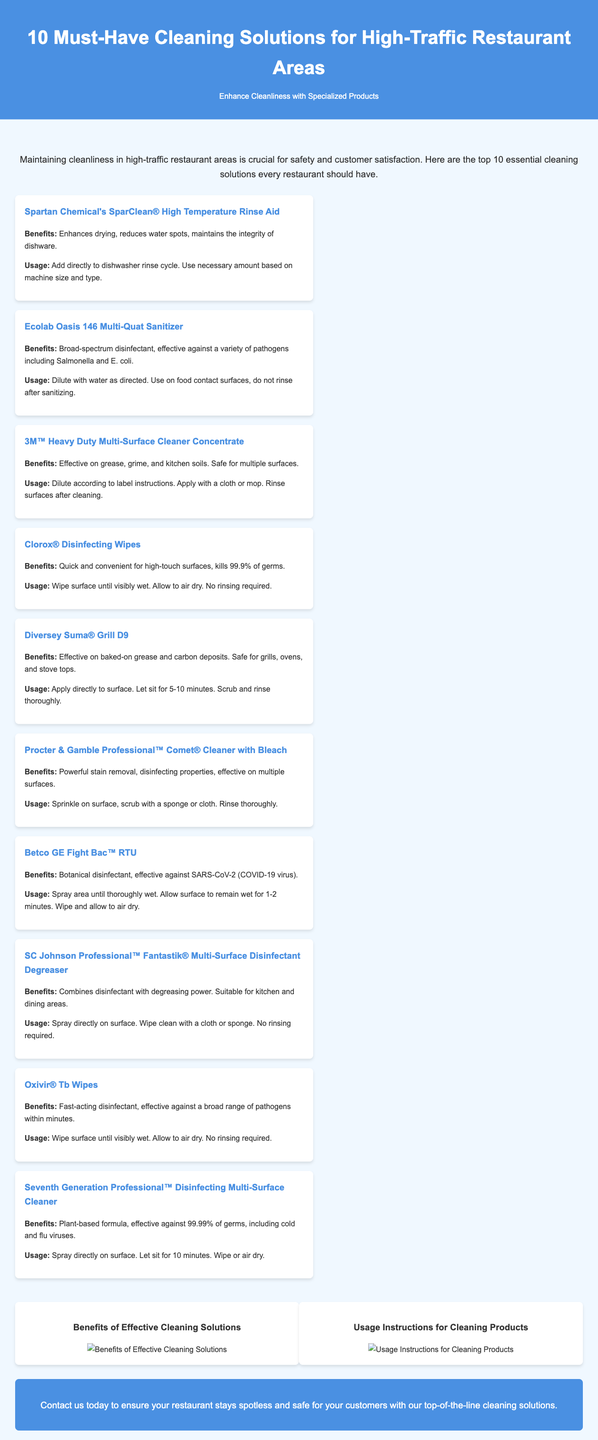What is the title of the document? The title is presented prominently at the top of the document, indicating the main topic.
Answer: 10 Must-Have Cleaning Solutions for High-Traffic Restaurant Areas How many cleaning solutions are listed? The introduction states that there are ten essential cleaning solutions mentioned in the document.
Answer: 10 What is a benefit of Spartan Chemical's SparClean® High Temperature Rinse Aid? Each product section discusses its benefits, and SparClean is noted for enhancing drying.
Answer: Enhances drying What type of disinfectant is Betco GE Fight Bac™ RTU? The document specifies that it is a botanical disinfectant, and this information is included in Betco's description.
Answer: Botanical What surfaces can the 3M™ Heavy Duty Multi-Surface Cleaner be used on? The document states that it is safe for multiple surfaces, which is noted in the benefits section.
Answer: Multiple surfaces How long should you let Seventh Generation Professional™ Disinfecting Multi-Surface Cleaner sit? The usage instructions explain the time required for the product to be effective.
Answer: 10 minutes What is the primary function of Clorox® Disinfecting Wipes? The document highlights that these wipes are designed for quick use on high-touch surfaces.
Answer: Quick and convenient What should you do after applying Diversey Suma® Grill D9? The instructions provide a clear follow-up on how to proceed post-application.
Answer: Scrub and rinse thoroughly What is the main message in the call to action section? The call to action urges restaurants to take an immediate step towards cleanliness.
Answer: Contact us today 